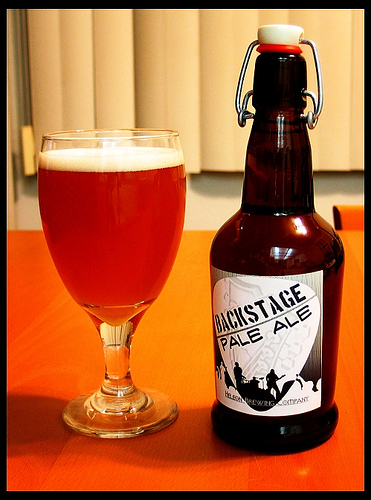<image>
Is there a cup behind the bottle? No. The cup is not behind the bottle. From this viewpoint, the cup appears to be positioned elsewhere in the scene. Is the bottle behind the glass? No. The bottle is not behind the glass. From this viewpoint, the bottle appears to be positioned elsewhere in the scene. Is the beer bottle behind the glass? No. The beer bottle is not behind the glass. From this viewpoint, the beer bottle appears to be positioned elsewhere in the scene. Is the glass to the right of the bottle? No. The glass is not to the right of the bottle. The horizontal positioning shows a different relationship. 